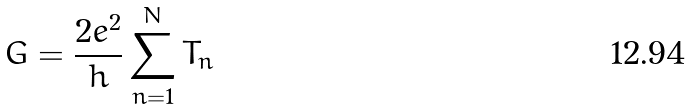<formula> <loc_0><loc_0><loc_500><loc_500>G = \frac { 2 e ^ { 2 } } { h } \sum ^ { N } _ { n = 1 } T _ { n }</formula> 